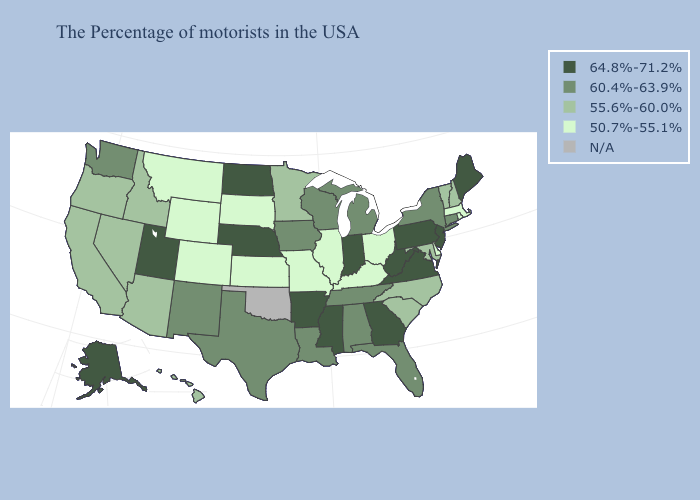Name the states that have a value in the range N/A?
Answer briefly. Oklahoma. Does the first symbol in the legend represent the smallest category?
Quick response, please. No. What is the lowest value in the Northeast?
Quick response, please. 50.7%-55.1%. Among the states that border Ohio , does Indiana have the highest value?
Give a very brief answer. Yes. What is the highest value in the West ?
Concise answer only. 64.8%-71.2%. Does the first symbol in the legend represent the smallest category?
Give a very brief answer. No. What is the lowest value in the USA?
Give a very brief answer. 50.7%-55.1%. What is the highest value in states that border Utah?
Quick response, please. 60.4%-63.9%. Name the states that have a value in the range 50.7%-55.1%?
Keep it brief. Massachusetts, Rhode Island, Delaware, Ohio, Kentucky, Illinois, Missouri, Kansas, South Dakota, Wyoming, Colorado, Montana. Is the legend a continuous bar?
Quick response, please. No. What is the lowest value in states that border Arkansas?
Keep it brief. 50.7%-55.1%. What is the value of Oregon?
Keep it brief. 55.6%-60.0%. Name the states that have a value in the range 50.7%-55.1%?
Write a very short answer. Massachusetts, Rhode Island, Delaware, Ohio, Kentucky, Illinois, Missouri, Kansas, South Dakota, Wyoming, Colorado, Montana. Does Kentucky have the lowest value in the South?
Keep it brief. Yes. 